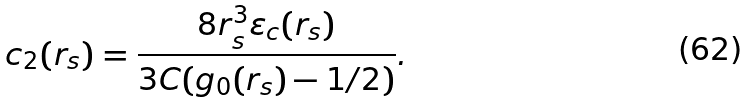<formula> <loc_0><loc_0><loc_500><loc_500>c _ { 2 } ( r _ { s } ) = \frac { 8 r _ { s } ^ { 3 } \varepsilon _ { c } ( r _ { s } ) } { 3 C ( g _ { 0 } ( r _ { s } ) - 1 / 2 ) } .</formula> 